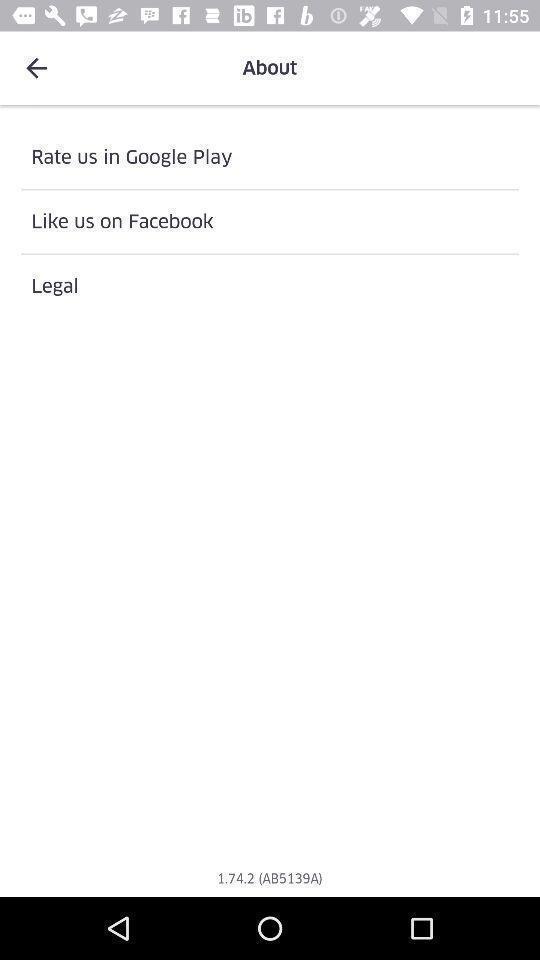Explain what's happening in this screen capture. Screen displaying the screen page of food app. 